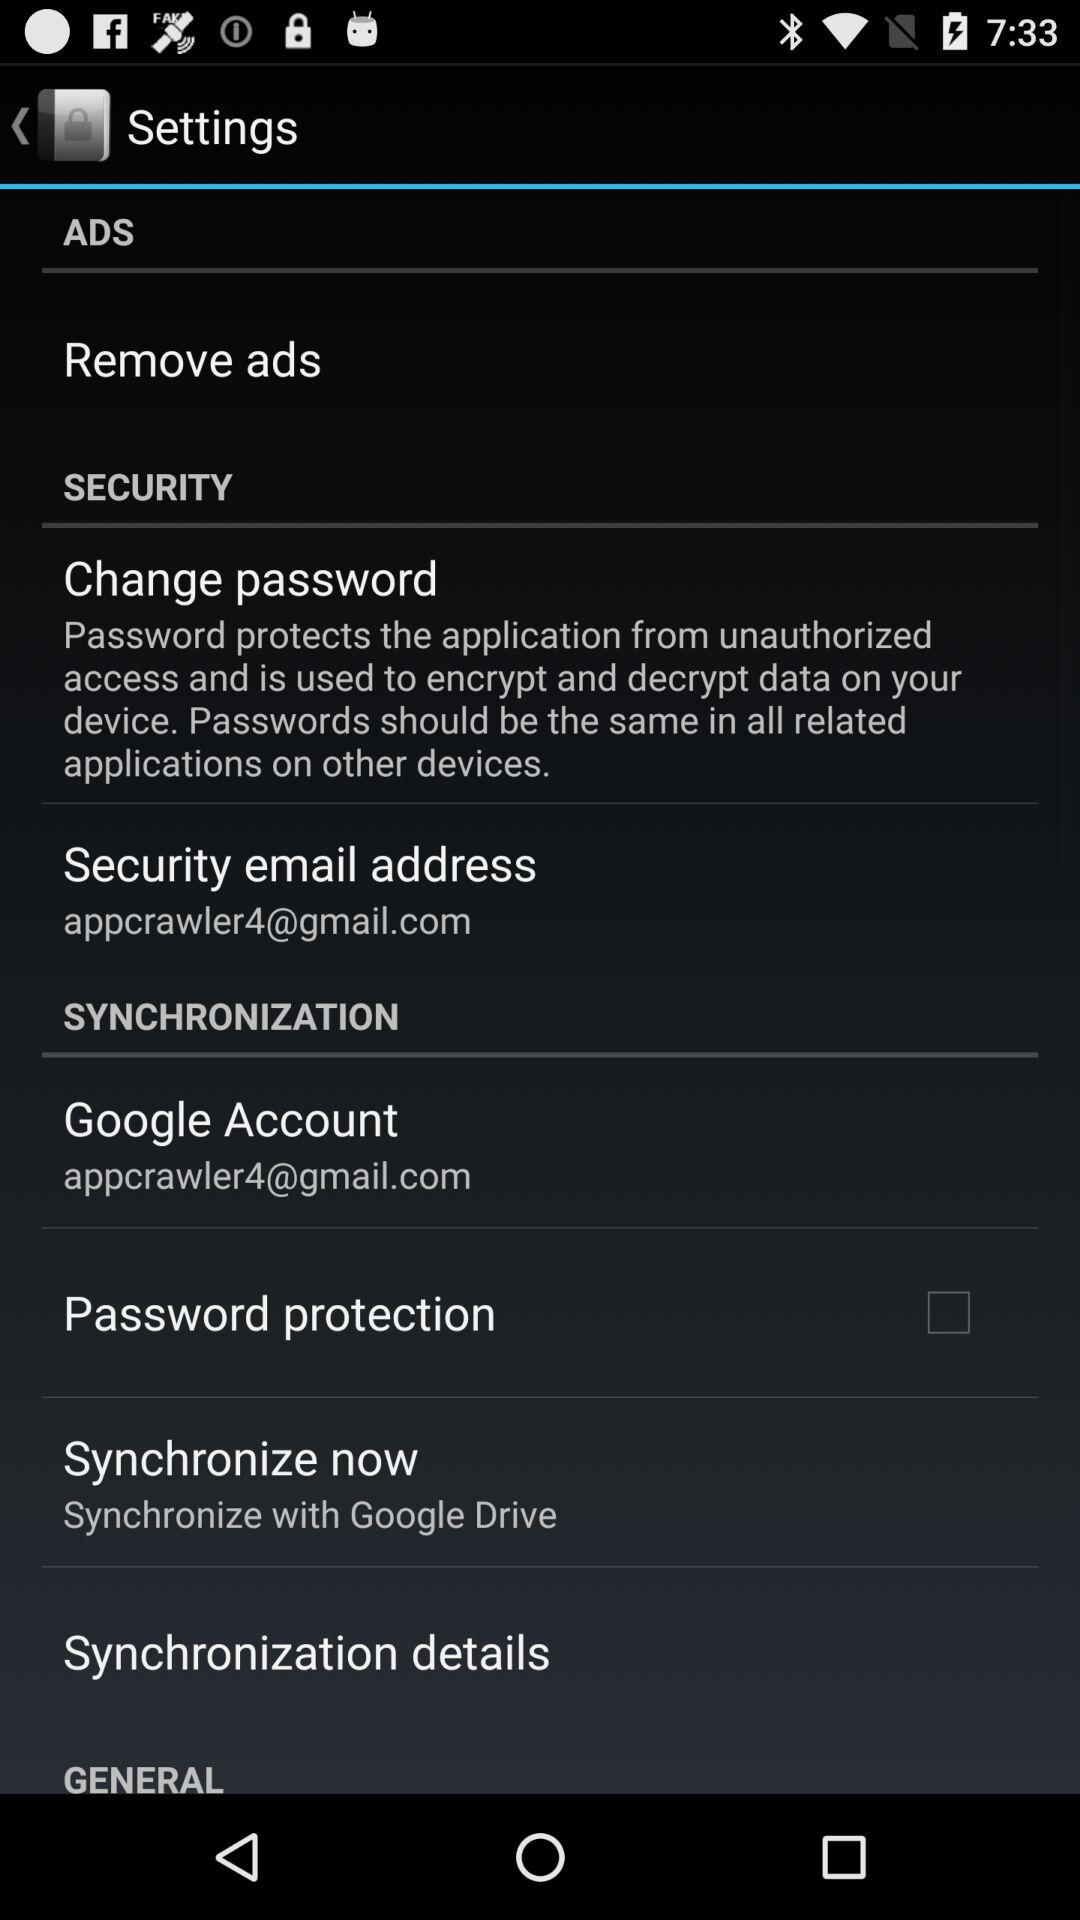What is the status of password protection? The status of password protection is "off". 